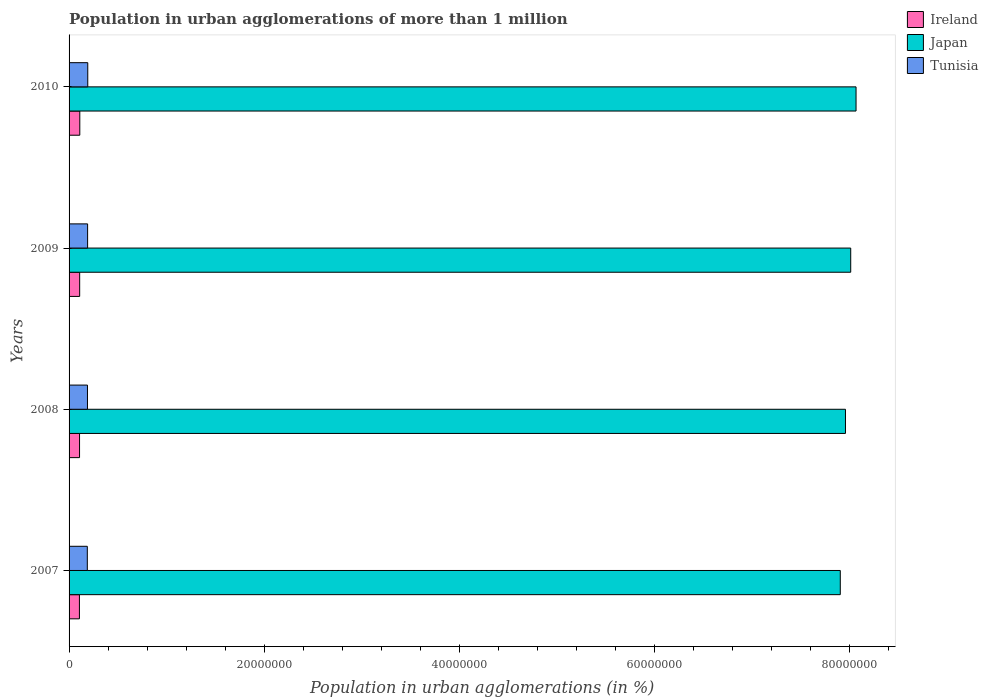How many groups of bars are there?
Provide a succinct answer. 4. Are the number of bars on each tick of the Y-axis equal?
Make the answer very short. Yes. How many bars are there on the 4th tick from the top?
Your answer should be very brief. 3. How many bars are there on the 2nd tick from the bottom?
Provide a short and direct response. 3. In how many cases, is the number of bars for a given year not equal to the number of legend labels?
Make the answer very short. 0. What is the population in urban agglomerations in Tunisia in 2010?
Provide a short and direct response. 1.92e+06. Across all years, what is the maximum population in urban agglomerations in Tunisia?
Keep it short and to the point. 1.92e+06. Across all years, what is the minimum population in urban agglomerations in Tunisia?
Ensure brevity in your answer.  1.87e+06. What is the total population in urban agglomerations in Ireland in the graph?
Offer a very short reply. 4.32e+06. What is the difference between the population in urban agglomerations in Japan in 2009 and that in 2010?
Your response must be concise. -5.47e+05. What is the difference between the population in urban agglomerations in Tunisia in 2009 and the population in urban agglomerations in Japan in 2007?
Your response must be concise. -7.72e+07. What is the average population in urban agglomerations in Ireland per year?
Your response must be concise. 1.08e+06. In the year 2009, what is the difference between the population in urban agglomerations in Tunisia and population in urban agglomerations in Ireland?
Your answer should be very brief. 8.14e+05. In how many years, is the population in urban agglomerations in Tunisia greater than 60000000 %?
Make the answer very short. 0. What is the ratio of the population in urban agglomerations in Ireland in 2008 to that in 2009?
Keep it short and to the point. 0.99. Is the difference between the population in urban agglomerations in Tunisia in 2009 and 2010 greater than the difference between the population in urban agglomerations in Ireland in 2009 and 2010?
Offer a very short reply. No. What is the difference between the highest and the second highest population in urban agglomerations in Tunisia?
Offer a very short reply. 1.52e+04. What is the difference between the highest and the lowest population in urban agglomerations in Ireland?
Give a very brief answer. 3.93e+04. In how many years, is the population in urban agglomerations in Ireland greater than the average population in urban agglomerations in Ireland taken over all years?
Offer a very short reply. 2. Is the sum of the population in urban agglomerations in Tunisia in 2008 and 2009 greater than the maximum population in urban agglomerations in Japan across all years?
Ensure brevity in your answer.  No. What does the 3rd bar from the top in 2010 represents?
Make the answer very short. Ireland. What does the 1st bar from the bottom in 2009 represents?
Keep it short and to the point. Ireland. How many bars are there?
Your answer should be compact. 12. Are all the bars in the graph horizontal?
Give a very brief answer. Yes. Does the graph contain any zero values?
Your answer should be very brief. No. Where does the legend appear in the graph?
Your answer should be compact. Top right. How many legend labels are there?
Offer a terse response. 3. How are the legend labels stacked?
Your answer should be compact. Vertical. What is the title of the graph?
Offer a terse response. Population in urban agglomerations of more than 1 million. What is the label or title of the X-axis?
Give a very brief answer. Population in urban agglomerations (in %). What is the label or title of the Y-axis?
Your answer should be very brief. Years. What is the Population in urban agglomerations (in %) in Ireland in 2007?
Your answer should be compact. 1.06e+06. What is the Population in urban agglomerations (in %) in Japan in 2007?
Your answer should be very brief. 7.91e+07. What is the Population in urban agglomerations (in %) of Tunisia in 2007?
Keep it short and to the point. 1.87e+06. What is the Population in urban agglomerations (in %) of Ireland in 2008?
Offer a terse response. 1.07e+06. What is the Population in urban agglomerations (in %) of Japan in 2008?
Provide a succinct answer. 7.96e+07. What is the Population in urban agglomerations (in %) of Tunisia in 2008?
Keep it short and to the point. 1.89e+06. What is the Population in urban agglomerations (in %) of Ireland in 2009?
Your response must be concise. 1.09e+06. What is the Population in urban agglomerations (in %) in Japan in 2009?
Provide a succinct answer. 8.01e+07. What is the Population in urban agglomerations (in %) in Tunisia in 2009?
Give a very brief answer. 1.90e+06. What is the Population in urban agglomerations (in %) of Ireland in 2010?
Your response must be concise. 1.10e+06. What is the Population in urban agglomerations (in %) in Japan in 2010?
Your response must be concise. 8.07e+07. What is the Population in urban agglomerations (in %) of Tunisia in 2010?
Your response must be concise. 1.92e+06. Across all years, what is the maximum Population in urban agglomerations (in %) of Ireland?
Offer a terse response. 1.10e+06. Across all years, what is the maximum Population in urban agglomerations (in %) in Japan?
Offer a terse response. 8.07e+07. Across all years, what is the maximum Population in urban agglomerations (in %) in Tunisia?
Your answer should be compact. 1.92e+06. Across all years, what is the minimum Population in urban agglomerations (in %) of Ireland?
Offer a terse response. 1.06e+06. Across all years, what is the minimum Population in urban agglomerations (in %) in Japan?
Ensure brevity in your answer.  7.91e+07. Across all years, what is the minimum Population in urban agglomerations (in %) of Tunisia?
Offer a terse response. 1.87e+06. What is the total Population in urban agglomerations (in %) in Ireland in the graph?
Ensure brevity in your answer.  4.32e+06. What is the total Population in urban agglomerations (in %) in Japan in the graph?
Your response must be concise. 3.19e+08. What is the total Population in urban agglomerations (in %) of Tunisia in the graph?
Give a very brief answer. 7.57e+06. What is the difference between the Population in urban agglomerations (in %) in Ireland in 2007 and that in 2008?
Keep it short and to the point. -1.30e+04. What is the difference between the Population in urban agglomerations (in %) in Japan in 2007 and that in 2008?
Offer a terse response. -5.32e+05. What is the difference between the Population in urban agglomerations (in %) in Tunisia in 2007 and that in 2008?
Provide a short and direct response. -1.50e+04. What is the difference between the Population in urban agglomerations (in %) of Ireland in 2007 and that in 2009?
Your response must be concise. -2.60e+04. What is the difference between the Population in urban agglomerations (in %) in Japan in 2007 and that in 2009?
Your answer should be compact. -1.07e+06. What is the difference between the Population in urban agglomerations (in %) in Tunisia in 2007 and that in 2009?
Offer a terse response. -3.01e+04. What is the difference between the Population in urban agglomerations (in %) in Ireland in 2007 and that in 2010?
Your answer should be very brief. -3.93e+04. What is the difference between the Population in urban agglomerations (in %) in Japan in 2007 and that in 2010?
Offer a very short reply. -1.62e+06. What is the difference between the Population in urban agglomerations (in %) of Tunisia in 2007 and that in 2010?
Offer a very short reply. -4.53e+04. What is the difference between the Population in urban agglomerations (in %) in Ireland in 2008 and that in 2009?
Provide a succinct answer. -1.31e+04. What is the difference between the Population in urban agglomerations (in %) in Japan in 2008 and that in 2009?
Your response must be concise. -5.38e+05. What is the difference between the Population in urban agglomerations (in %) in Tunisia in 2008 and that in 2009?
Make the answer very short. -1.51e+04. What is the difference between the Population in urban agglomerations (in %) of Ireland in 2008 and that in 2010?
Offer a terse response. -2.63e+04. What is the difference between the Population in urban agglomerations (in %) in Japan in 2008 and that in 2010?
Give a very brief answer. -1.09e+06. What is the difference between the Population in urban agglomerations (in %) of Tunisia in 2008 and that in 2010?
Your answer should be compact. -3.03e+04. What is the difference between the Population in urban agglomerations (in %) of Ireland in 2009 and that in 2010?
Offer a very short reply. -1.33e+04. What is the difference between the Population in urban agglomerations (in %) of Japan in 2009 and that in 2010?
Your response must be concise. -5.47e+05. What is the difference between the Population in urban agglomerations (in %) of Tunisia in 2009 and that in 2010?
Provide a short and direct response. -1.52e+04. What is the difference between the Population in urban agglomerations (in %) of Ireland in 2007 and the Population in urban agglomerations (in %) of Japan in 2008?
Your answer should be very brief. -7.85e+07. What is the difference between the Population in urban agglomerations (in %) in Ireland in 2007 and the Population in urban agglomerations (in %) in Tunisia in 2008?
Keep it short and to the point. -8.25e+05. What is the difference between the Population in urban agglomerations (in %) of Japan in 2007 and the Population in urban agglomerations (in %) of Tunisia in 2008?
Offer a terse response. 7.72e+07. What is the difference between the Population in urban agglomerations (in %) in Ireland in 2007 and the Population in urban agglomerations (in %) in Japan in 2009?
Provide a succinct answer. -7.91e+07. What is the difference between the Population in urban agglomerations (in %) in Ireland in 2007 and the Population in urban agglomerations (in %) in Tunisia in 2009?
Your answer should be very brief. -8.40e+05. What is the difference between the Population in urban agglomerations (in %) of Japan in 2007 and the Population in urban agglomerations (in %) of Tunisia in 2009?
Keep it short and to the point. 7.72e+07. What is the difference between the Population in urban agglomerations (in %) of Ireland in 2007 and the Population in urban agglomerations (in %) of Japan in 2010?
Make the answer very short. -7.96e+07. What is the difference between the Population in urban agglomerations (in %) in Ireland in 2007 and the Population in urban agglomerations (in %) in Tunisia in 2010?
Provide a succinct answer. -8.55e+05. What is the difference between the Population in urban agglomerations (in %) of Japan in 2007 and the Population in urban agglomerations (in %) of Tunisia in 2010?
Make the answer very short. 7.71e+07. What is the difference between the Population in urban agglomerations (in %) in Ireland in 2008 and the Population in urban agglomerations (in %) in Japan in 2009?
Your answer should be very brief. -7.91e+07. What is the difference between the Population in urban agglomerations (in %) of Ireland in 2008 and the Population in urban agglomerations (in %) of Tunisia in 2009?
Your response must be concise. -8.27e+05. What is the difference between the Population in urban agglomerations (in %) in Japan in 2008 and the Population in urban agglomerations (in %) in Tunisia in 2009?
Your answer should be very brief. 7.77e+07. What is the difference between the Population in urban agglomerations (in %) in Ireland in 2008 and the Population in urban agglomerations (in %) in Japan in 2010?
Your answer should be compact. -7.96e+07. What is the difference between the Population in urban agglomerations (in %) of Ireland in 2008 and the Population in urban agglomerations (in %) of Tunisia in 2010?
Offer a very short reply. -8.42e+05. What is the difference between the Population in urban agglomerations (in %) of Japan in 2008 and the Population in urban agglomerations (in %) of Tunisia in 2010?
Your answer should be compact. 7.77e+07. What is the difference between the Population in urban agglomerations (in %) of Ireland in 2009 and the Population in urban agglomerations (in %) of Japan in 2010?
Provide a succinct answer. -7.96e+07. What is the difference between the Population in urban agglomerations (in %) of Ireland in 2009 and the Population in urban agglomerations (in %) of Tunisia in 2010?
Give a very brief answer. -8.29e+05. What is the difference between the Population in urban agglomerations (in %) in Japan in 2009 and the Population in urban agglomerations (in %) in Tunisia in 2010?
Your answer should be compact. 7.82e+07. What is the average Population in urban agglomerations (in %) of Ireland per year?
Provide a succinct answer. 1.08e+06. What is the average Population in urban agglomerations (in %) in Japan per year?
Keep it short and to the point. 7.99e+07. What is the average Population in urban agglomerations (in %) in Tunisia per year?
Your answer should be compact. 1.89e+06. In the year 2007, what is the difference between the Population in urban agglomerations (in %) of Ireland and Population in urban agglomerations (in %) of Japan?
Make the answer very short. -7.80e+07. In the year 2007, what is the difference between the Population in urban agglomerations (in %) in Ireland and Population in urban agglomerations (in %) in Tunisia?
Ensure brevity in your answer.  -8.10e+05. In the year 2007, what is the difference between the Population in urban agglomerations (in %) in Japan and Population in urban agglomerations (in %) in Tunisia?
Give a very brief answer. 7.72e+07. In the year 2008, what is the difference between the Population in urban agglomerations (in %) of Ireland and Population in urban agglomerations (in %) of Japan?
Your answer should be very brief. -7.85e+07. In the year 2008, what is the difference between the Population in urban agglomerations (in %) of Ireland and Population in urban agglomerations (in %) of Tunisia?
Keep it short and to the point. -8.12e+05. In the year 2008, what is the difference between the Population in urban agglomerations (in %) of Japan and Population in urban agglomerations (in %) of Tunisia?
Offer a very short reply. 7.77e+07. In the year 2009, what is the difference between the Population in urban agglomerations (in %) in Ireland and Population in urban agglomerations (in %) in Japan?
Your answer should be compact. -7.90e+07. In the year 2009, what is the difference between the Population in urban agglomerations (in %) in Ireland and Population in urban agglomerations (in %) in Tunisia?
Your answer should be very brief. -8.14e+05. In the year 2009, what is the difference between the Population in urban agglomerations (in %) in Japan and Population in urban agglomerations (in %) in Tunisia?
Give a very brief answer. 7.82e+07. In the year 2010, what is the difference between the Population in urban agglomerations (in %) in Ireland and Population in urban agglomerations (in %) in Japan?
Your answer should be compact. -7.96e+07. In the year 2010, what is the difference between the Population in urban agglomerations (in %) in Ireland and Population in urban agglomerations (in %) in Tunisia?
Provide a short and direct response. -8.16e+05. In the year 2010, what is the difference between the Population in urban agglomerations (in %) in Japan and Population in urban agglomerations (in %) in Tunisia?
Your response must be concise. 7.88e+07. What is the ratio of the Population in urban agglomerations (in %) in Ireland in 2007 to that in 2008?
Your answer should be compact. 0.99. What is the ratio of the Population in urban agglomerations (in %) in Japan in 2007 to that in 2008?
Provide a short and direct response. 0.99. What is the ratio of the Population in urban agglomerations (in %) in Ireland in 2007 to that in 2009?
Provide a succinct answer. 0.98. What is the ratio of the Population in urban agglomerations (in %) in Japan in 2007 to that in 2009?
Provide a succinct answer. 0.99. What is the ratio of the Population in urban agglomerations (in %) of Tunisia in 2007 to that in 2009?
Your response must be concise. 0.98. What is the ratio of the Population in urban agglomerations (in %) in Tunisia in 2007 to that in 2010?
Your response must be concise. 0.98. What is the ratio of the Population in urban agglomerations (in %) in Ireland in 2008 to that in 2010?
Keep it short and to the point. 0.98. What is the ratio of the Population in urban agglomerations (in %) in Japan in 2008 to that in 2010?
Your response must be concise. 0.99. What is the ratio of the Population in urban agglomerations (in %) of Tunisia in 2008 to that in 2010?
Your response must be concise. 0.98. What is the ratio of the Population in urban agglomerations (in %) in Tunisia in 2009 to that in 2010?
Give a very brief answer. 0.99. What is the difference between the highest and the second highest Population in urban agglomerations (in %) in Ireland?
Your answer should be very brief. 1.33e+04. What is the difference between the highest and the second highest Population in urban agglomerations (in %) in Japan?
Keep it short and to the point. 5.47e+05. What is the difference between the highest and the second highest Population in urban agglomerations (in %) in Tunisia?
Keep it short and to the point. 1.52e+04. What is the difference between the highest and the lowest Population in urban agglomerations (in %) in Ireland?
Keep it short and to the point. 3.93e+04. What is the difference between the highest and the lowest Population in urban agglomerations (in %) in Japan?
Provide a short and direct response. 1.62e+06. What is the difference between the highest and the lowest Population in urban agglomerations (in %) of Tunisia?
Keep it short and to the point. 4.53e+04. 